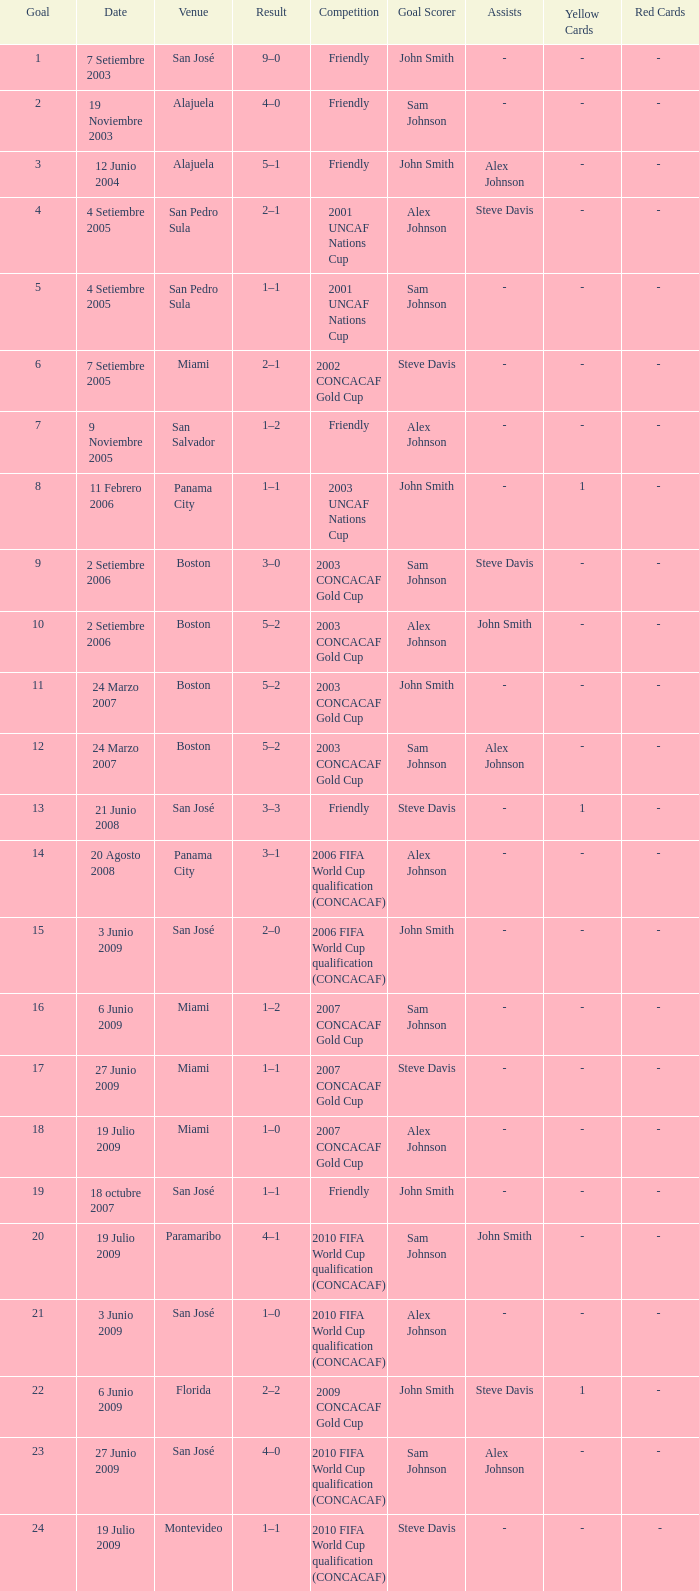At the venue of panama city, on 11 Febrero 2006, how many goals were scored? 1.0. 